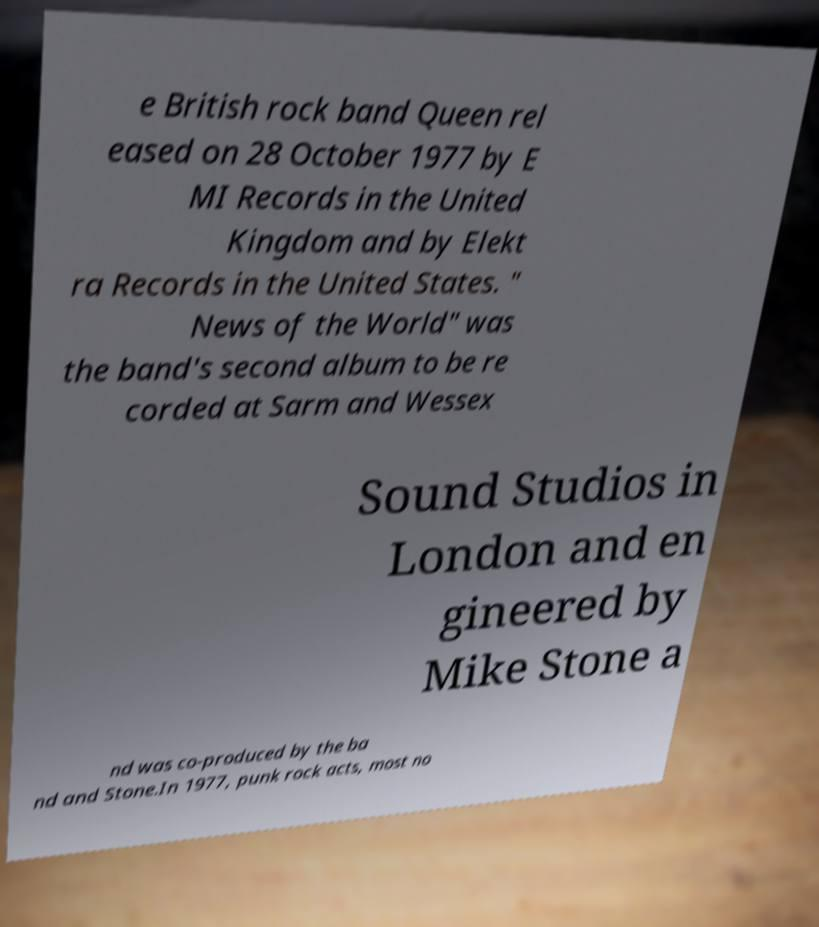Please read and relay the text visible in this image. What does it say? e British rock band Queen rel eased on 28 October 1977 by E MI Records in the United Kingdom and by Elekt ra Records in the United States. " News of the World" was the band's second album to be re corded at Sarm and Wessex Sound Studios in London and en gineered by Mike Stone a nd was co-produced by the ba nd and Stone.In 1977, punk rock acts, most no 